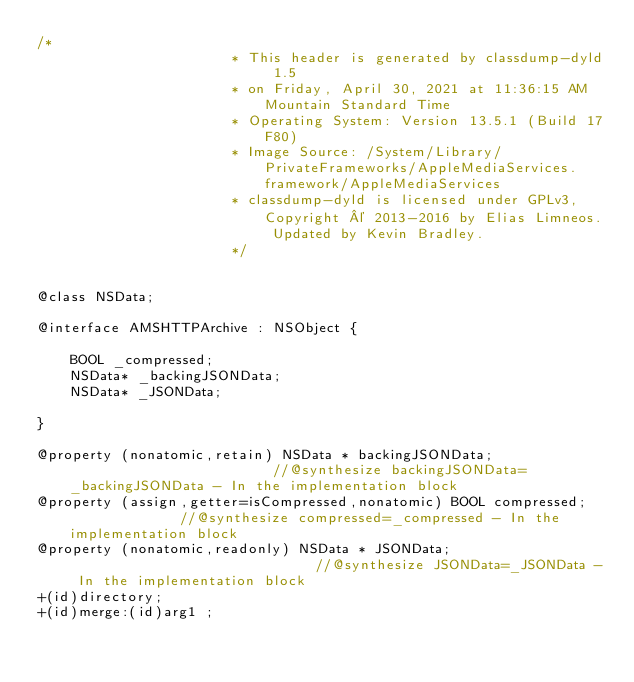Convert code to text. <code><loc_0><loc_0><loc_500><loc_500><_C_>/*
                       * This header is generated by classdump-dyld 1.5
                       * on Friday, April 30, 2021 at 11:36:15 AM Mountain Standard Time
                       * Operating System: Version 13.5.1 (Build 17F80)
                       * Image Source: /System/Library/PrivateFrameworks/AppleMediaServices.framework/AppleMediaServices
                       * classdump-dyld is licensed under GPLv3, Copyright © 2013-2016 by Elias Limneos. Updated by Kevin Bradley.
                       */


@class NSData;

@interface AMSHTTPArchive : NSObject {

	BOOL _compressed;
	NSData* _backingJSONData;
	NSData* _JSONData;

}

@property (nonatomic,retain) NSData * backingJSONData;                         //@synthesize backingJSONData=_backingJSONData - In the implementation block
@property (assign,getter=isCompressed,nonatomic) BOOL compressed;              //@synthesize compressed=_compressed - In the implementation block
@property (nonatomic,readonly) NSData * JSONData;                              //@synthesize JSONData=_JSONData - In the implementation block
+(id)directory;
+(id)merge:(id)arg1 ;</code> 